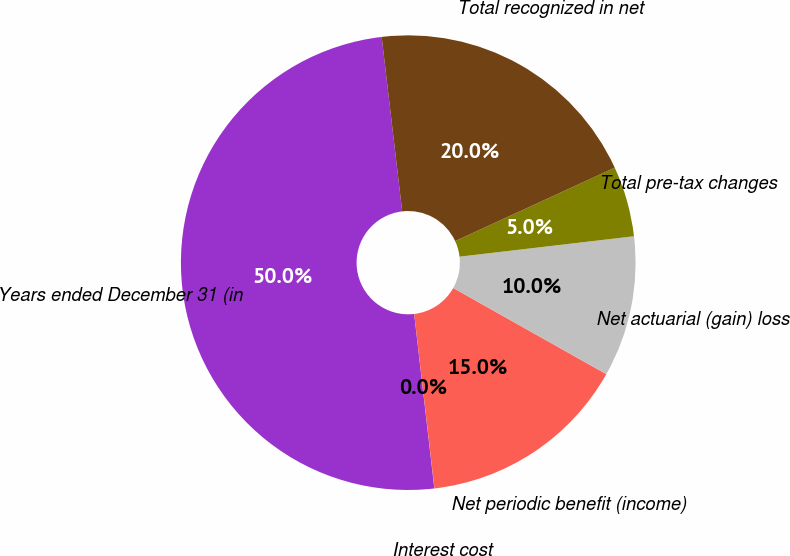<chart> <loc_0><loc_0><loc_500><loc_500><pie_chart><fcel>Years ended December 31 (in<fcel>Interest cost<fcel>Net periodic benefit (income)<fcel>Net actuarial (gain) loss<fcel>Total pre-tax changes<fcel>Total recognized in net<nl><fcel>49.97%<fcel>0.01%<fcel>15.0%<fcel>10.01%<fcel>5.01%<fcel>20.0%<nl></chart> 